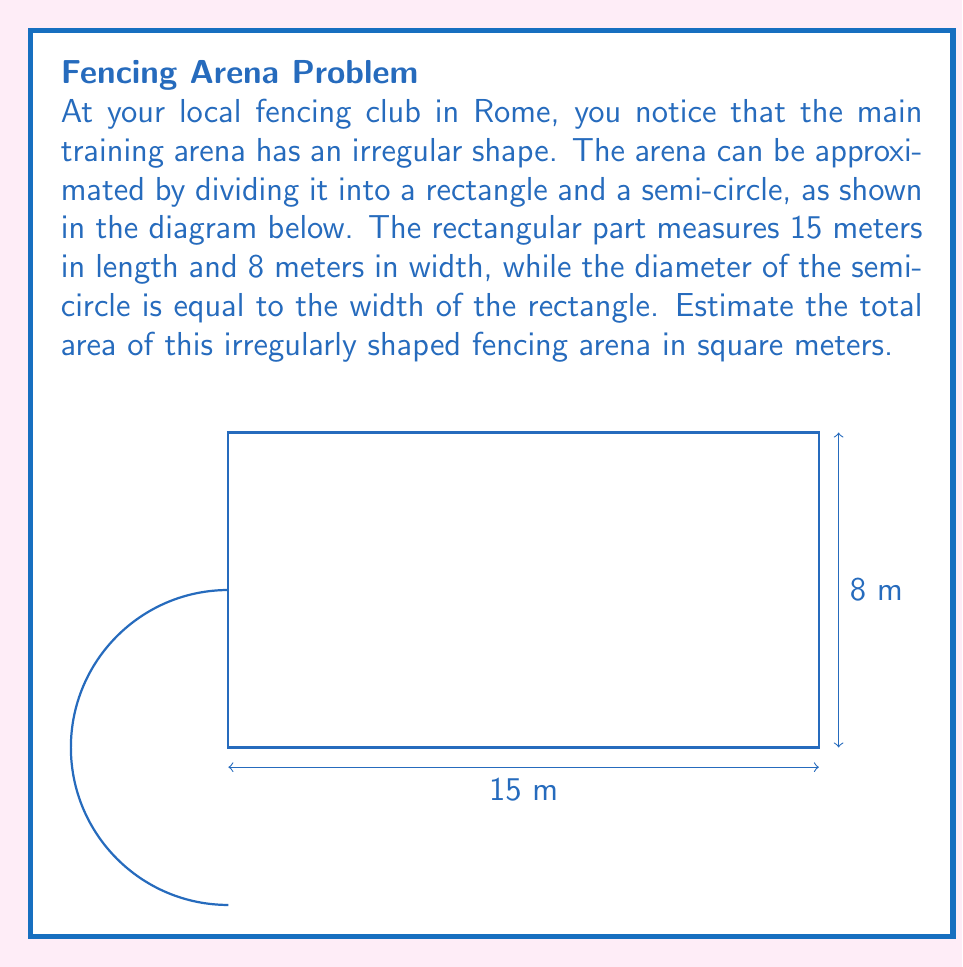Teach me how to tackle this problem. Let's break this problem down step-by-step:

1) First, we need to calculate the area of the rectangular part:
   Area of rectangle = length × width
   $A_r = 15 \text{ m} \times 8 \text{ m} = 120 \text{ m}^2$

2) Next, we need to calculate the area of the semi-circle:
   - The diameter of the semi-circle is equal to the width of the rectangle, which is 8 m.
   - So, the radius of the semi-circle is half of this, which is 4 m.
   - The formula for the area of a circle is $A = \pi r^2$
   - For a semi-circle, we take half of this:
     $A_s = \frac{1}{2} \pi r^2 = \frac{1}{2} \times \pi \times 4^2 \text{ m}^2 = 8\pi \text{ m}^2$

3) Now, we can add these two areas together:
   Total Area = Area of rectangle + Area of semi-circle
   $A_t = 120 \text{ m}^2 + 8\pi \text{ m}^2$

4) To get a numerical answer, let's use $\pi \approx 3.14$:
   $A_t \approx 120 \text{ m}^2 + 8 \times 3.14 \text{ m}^2 = 120 \text{ m}^2 + 25.12 \text{ m}^2 = 145.12 \text{ m}^2$

5) Rounding to the nearest square meter:
   $A_t \approx 145 \text{ m}^2$
Answer: $145 \text{ m}^2$ 